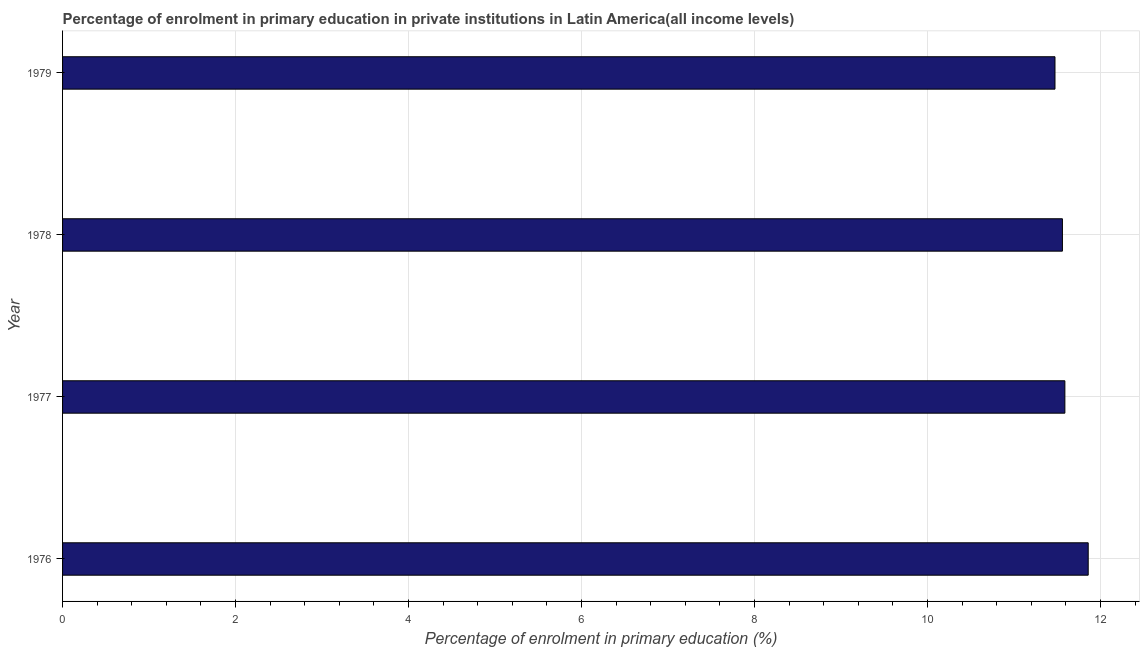Does the graph contain any zero values?
Provide a short and direct response. No. What is the title of the graph?
Your answer should be very brief. Percentage of enrolment in primary education in private institutions in Latin America(all income levels). What is the label or title of the X-axis?
Offer a terse response. Percentage of enrolment in primary education (%). What is the enrolment percentage in primary education in 1979?
Your answer should be compact. 11.47. Across all years, what is the maximum enrolment percentage in primary education?
Your answer should be very brief. 11.86. Across all years, what is the minimum enrolment percentage in primary education?
Provide a short and direct response. 11.47. In which year was the enrolment percentage in primary education maximum?
Offer a very short reply. 1976. In which year was the enrolment percentage in primary education minimum?
Offer a very short reply. 1979. What is the sum of the enrolment percentage in primary education?
Your response must be concise. 46.48. What is the difference between the enrolment percentage in primary education in 1978 and 1979?
Give a very brief answer. 0.09. What is the average enrolment percentage in primary education per year?
Offer a terse response. 11.62. What is the median enrolment percentage in primary education?
Provide a short and direct response. 11.57. In how many years, is the enrolment percentage in primary education greater than 7.6 %?
Your answer should be very brief. 4. Do a majority of the years between 1977 and 1978 (inclusive) have enrolment percentage in primary education greater than 2.8 %?
Ensure brevity in your answer.  Yes. What is the ratio of the enrolment percentage in primary education in 1976 to that in 1977?
Your answer should be compact. 1.02. Is the enrolment percentage in primary education in 1976 less than that in 1978?
Ensure brevity in your answer.  No. What is the difference between the highest and the second highest enrolment percentage in primary education?
Your answer should be very brief. 0.27. What is the difference between the highest and the lowest enrolment percentage in primary education?
Your answer should be very brief. 0.38. Are all the bars in the graph horizontal?
Make the answer very short. Yes. What is the Percentage of enrolment in primary education (%) in 1976?
Make the answer very short. 11.86. What is the Percentage of enrolment in primary education (%) of 1977?
Provide a succinct answer. 11.59. What is the Percentage of enrolment in primary education (%) in 1978?
Offer a very short reply. 11.56. What is the Percentage of enrolment in primary education (%) in 1979?
Offer a terse response. 11.47. What is the difference between the Percentage of enrolment in primary education (%) in 1976 and 1977?
Make the answer very short. 0.27. What is the difference between the Percentage of enrolment in primary education (%) in 1976 and 1978?
Ensure brevity in your answer.  0.3. What is the difference between the Percentage of enrolment in primary education (%) in 1976 and 1979?
Make the answer very short. 0.38. What is the difference between the Percentage of enrolment in primary education (%) in 1977 and 1978?
Keep it short and to the point. 0.03. What is the difference between the Percentage of enrolment in primary education (%) in 1977 and 1979?
Keep it short and to the point. 0.11. What is the difference between the Percentage of enrolment in primary education (%) in 1978 and 1979?
Your answer should be very brief. 0.09. What is the ratio of the Percentage of enrolment in primary education (%) in 1976 to that in 1978?
Make the answer very short. 1.03. What is the ratio of the Percentage of enrolment in primary education (%) in 1976 to that in 1979?
Provide a succinct answer. 1.03. What is the ratio of the Percentage of enrolment in primary education (%) in 1978 to that in 1979?
Give a very brief answer. 1.01. 